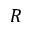<formula> <loc_0><loc_0><loc_500><loc_500>R</formula> 